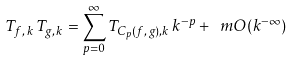Convert formula to latex. <formula><loc_0><loc_0><loc_500><loc_500>T _ { f , \, k } \, T _ { g , \, k } = \sum _ { p = 0 } ^ { \infty } T _ { C _ { p } ( f , \, g ) , k } \, k ^ { - p } + \ m O ( k ^ { - \infty } )</formula> 